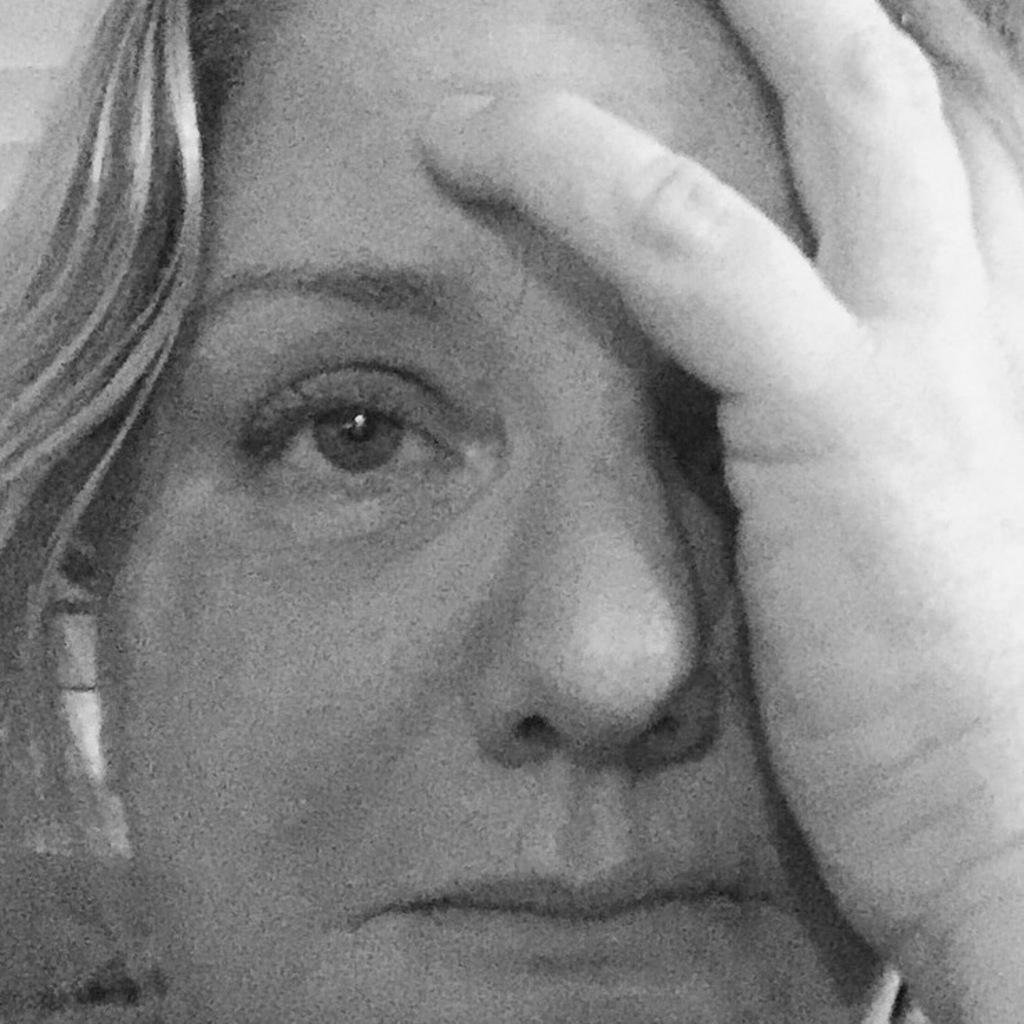What is the main subject of the image? The main subject of the image is a woman. Is the woman sitting on a bulb in the image? No, the woman is not sitting on a bulb in the image. 